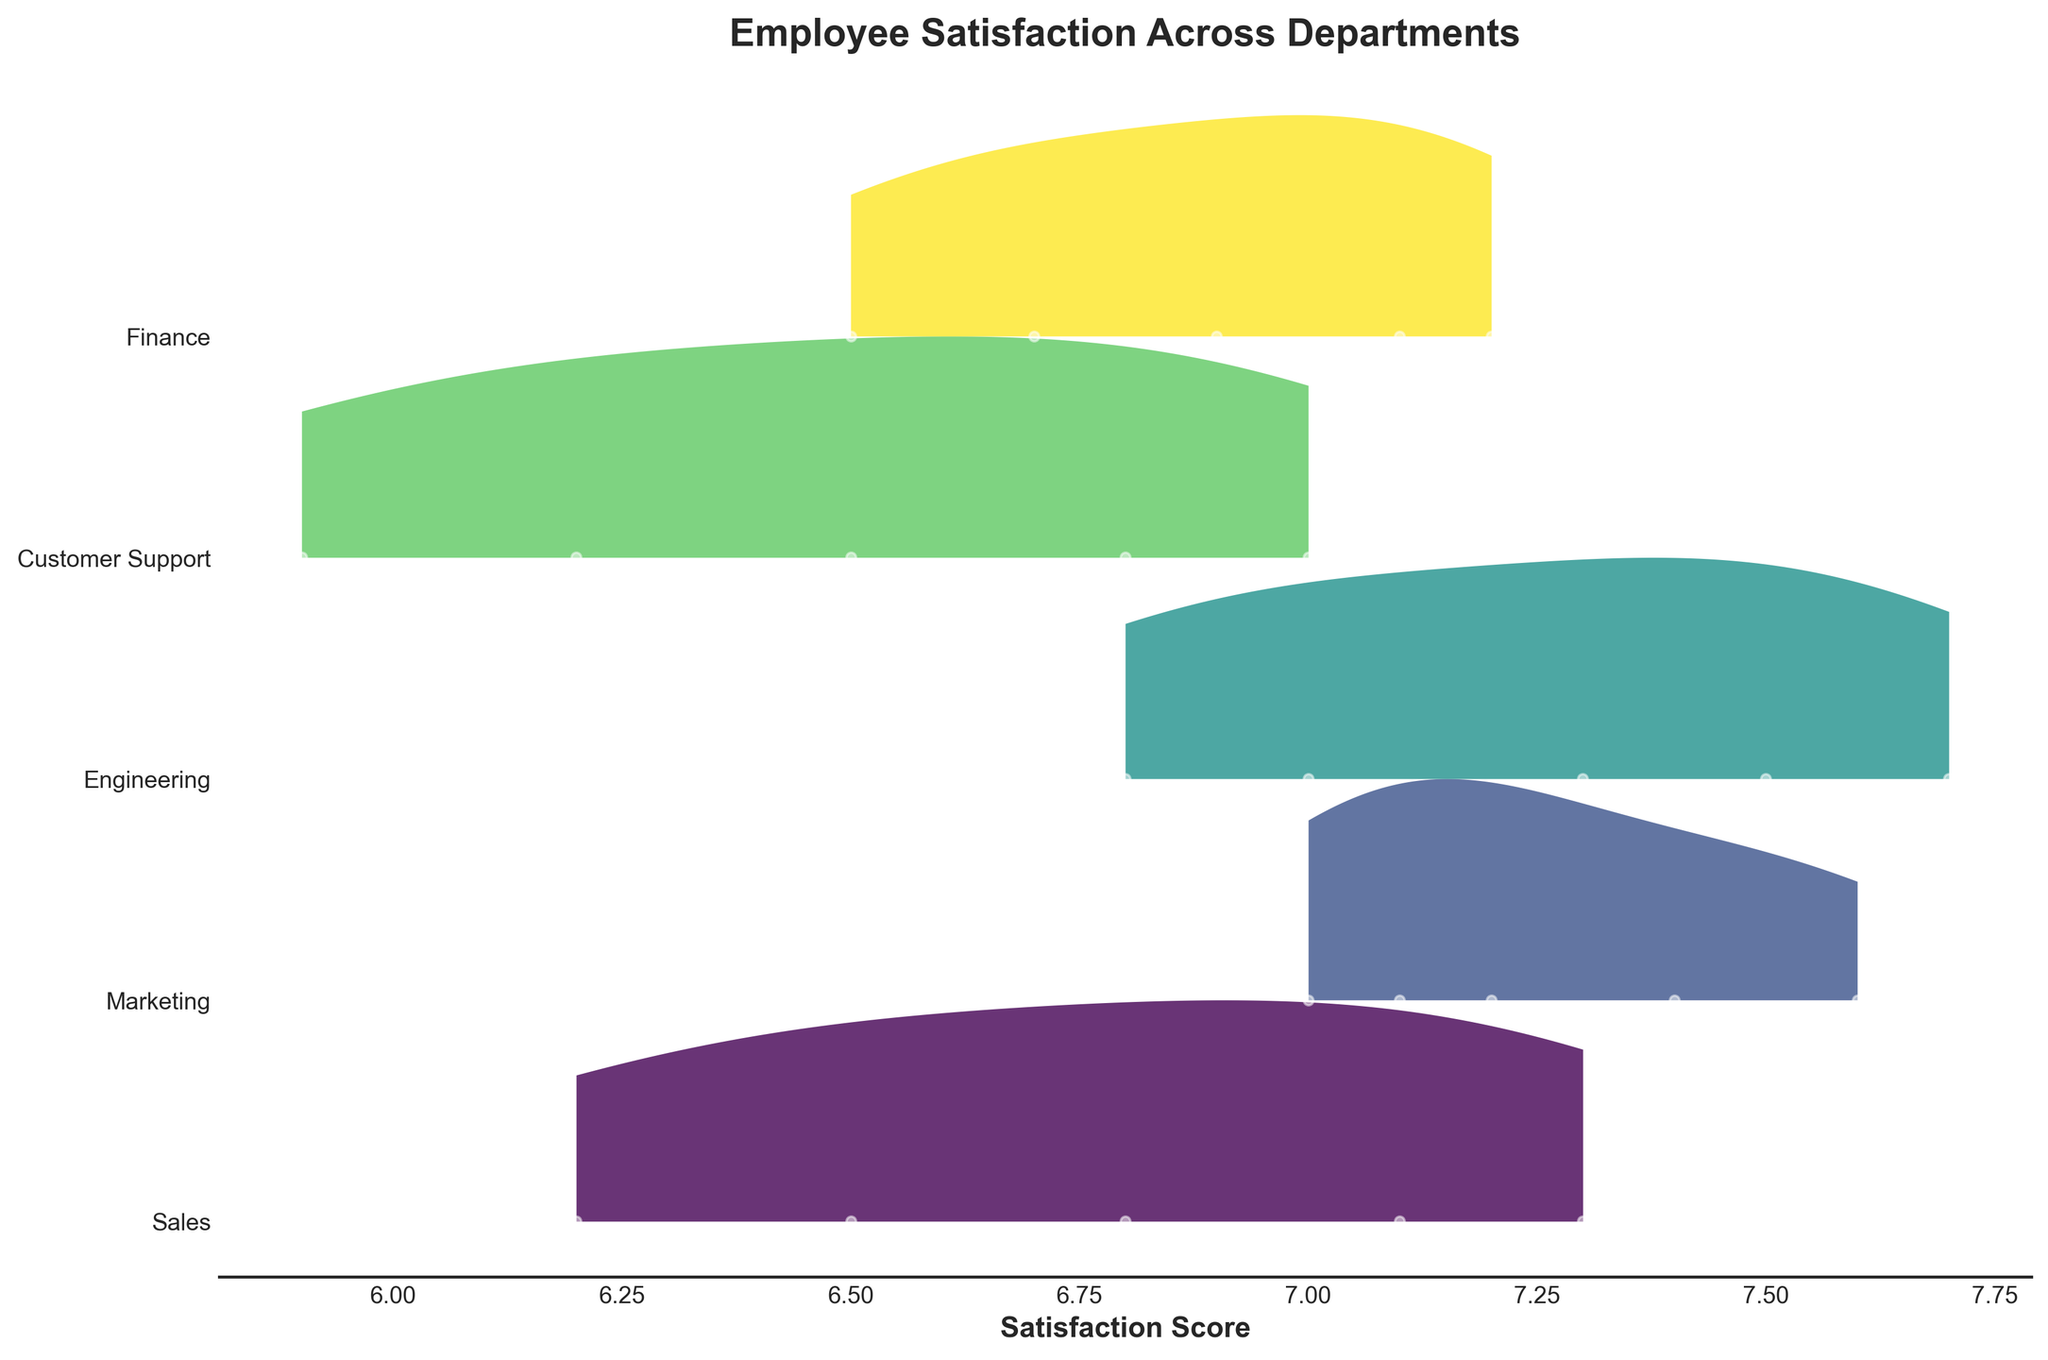What is the title of the figure? The title is the main heading of the figure, typically placed at the top, which summarizes the content or main focus of the visualization.
Answer: Employee Satisfaction Across Departments Which department has the highest satisfaction score in May? Locate "May" on the x-axis and find the highest point in that month across all departments. The highest point in May is in the Engineering department with a score of 7.7.
Answer: Engineering How does the satisfaction score trend over time for the Sales department? Track the Sales department over the months on the x-axis. You will notice an upward trend from 6.2 in January to 7.3 in May.
Answer: Increasing Compare the satisfaction scores of Marketing and Finance departments in March. Which is higher? Identify the satisfaction scores for Marketing (7.2) and Finance (6.9) in March. Compare these values to determine which is higher.
Answer: Marketing Which department shows the greatest increase in satisfaction score from January to May? Calculate the difference between January and May satisfaction scores for each department: 
Sales: 7.3 - 6.2 = 1.1 
Marketing: 7.6 - 7.1 = 0.5 
Engineering: 7.7 - 6.8 = 0.9 
Customer Support: 7.0 - 5.9 = 1.1 
Finance: 7.2 - 6.5 = 0.7. Both Sales and Customer Support show the highest increase of 1.1.
Answer: Sales and Customer Support Which department had the most stable satisfaction scores over the months observed? Consider the variability (range) of satisfaction scores for each department from January to May. The Marketing department's scores range from 7.0 to 7.6, showing the least variability compared to others.
Answer: Marketing Is there any month in which all departments have increasing satisfaction scores compared to the previous month? Examine the satisfaction scores month by month for all departments to see if each value increases from the previous month. For April, each department shows an increase from March.
Answer: April 